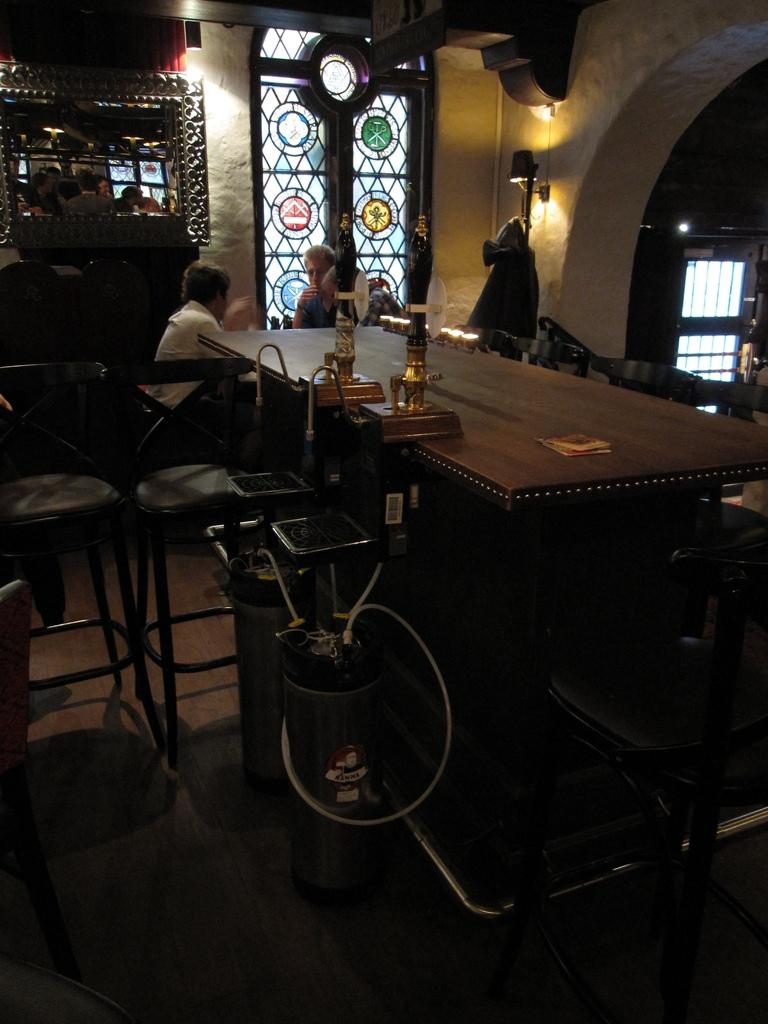How many people are in the image? There are two people in the image. What are the two people doing? The two people are sitting on a chair and talking. What is in front of the two people? There is a table in front of the two people. What type of honey is being discussed by the two people in the image? There is no mention of honey in the image, so it cannot be determined what type of honey is being discussed. 